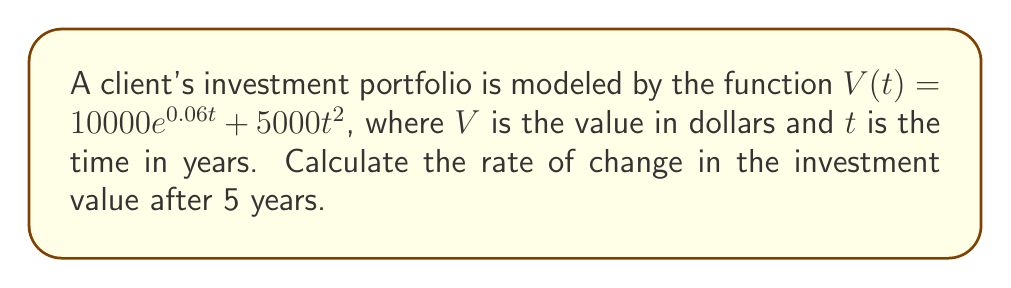What is the answer to this math problem? To find the rate of change in the investment value, we need to calculate the derivative of the function $V(t)$ and then evaluate it at $t = 5$.

Step 1: Calculate the derivative of $V(t)$
$$\frac{d}{dt}V(t) = \frac{d}{dt}(10000e^{0.06t} + 5000t^2)$$

Using the sum rule and chain rule:
$$V'(t) = 10000 \cdot 0.06e^{0.06t} + 5000 \cdot 2t$$
$$V'(t) = 600e^{0.06t} + 10000t$$

Step 2: Evaluate $V'(t)$ at $t = 5$
$$V'(5) = 600e^{0.06 \cdot 5} + 10000 \cdot 5$$
$$V'(5) = 600e^{0.3} + 50000$$

Step 3: Calculate the final value
$$V'(5) \approx 600 \cdot 1.34986 + 50000$$
$$V'(5) \approx 809.916 + 50000$$
$$V'(5) \approx 50809.92$$

The rate of change in the investment value after 5 years is approximately $50,809.92 per year.
Answer: $50,809.92 per year 